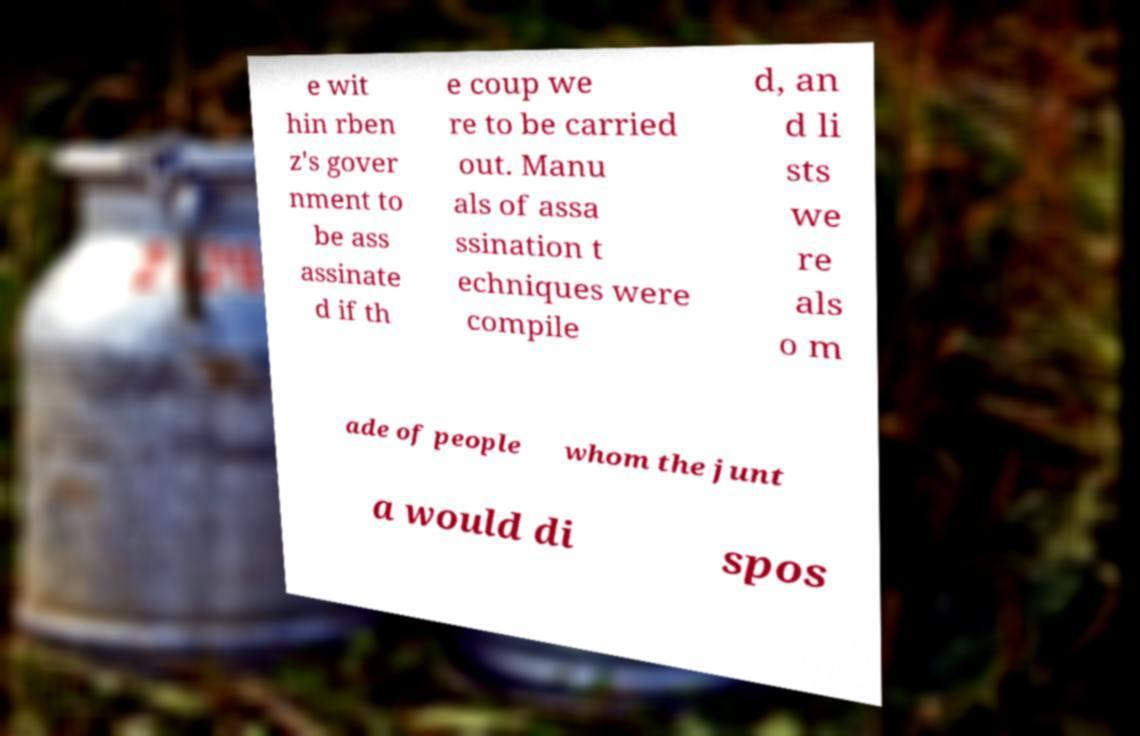Could you extract and type out the text from this image? e wit hin rben z's gover nment to be ass assinate d if th e coup we re to be carried out. Manu als of assa ssination t echniques were compile d, an d li sts we re als o m ade of people whom the junt a would di spos 